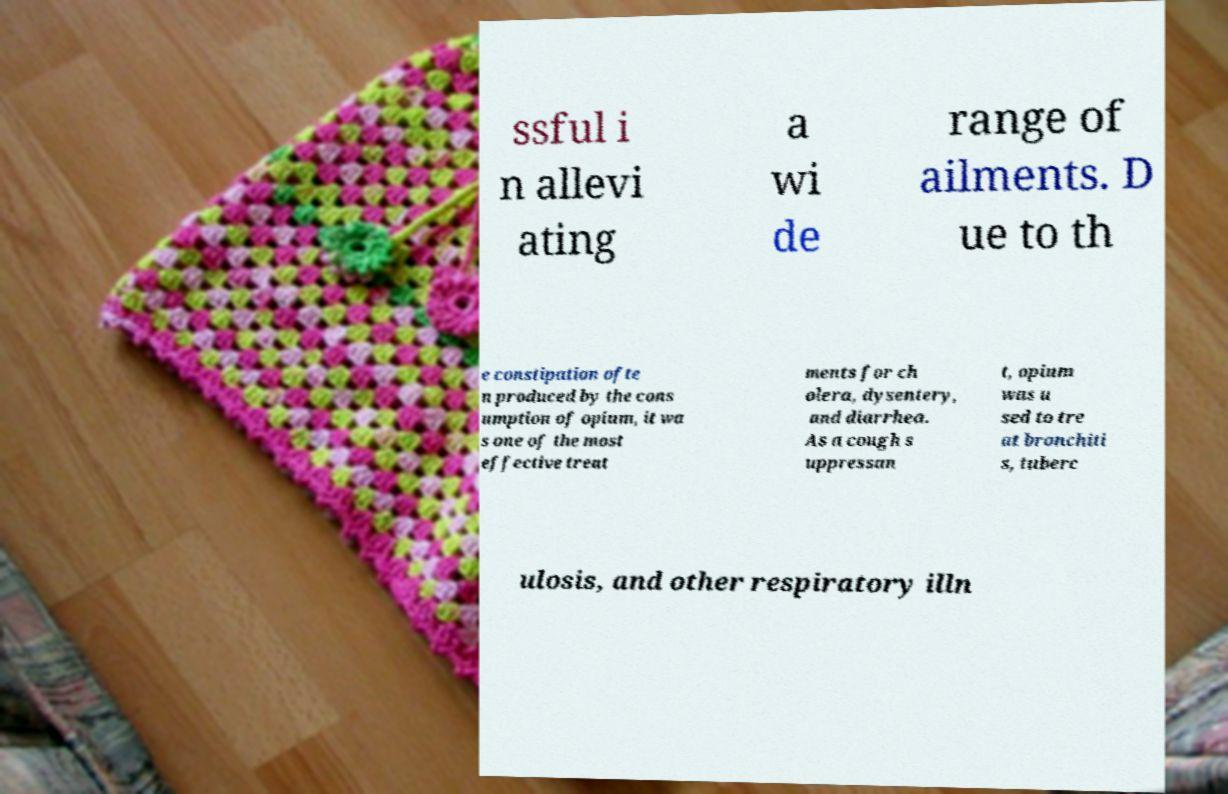Please identify and transcribe the text found in this image. ssful i n allevi ating a wi de range of ailments. D ue to th e constipation ofte n produced by the cons umption of opium, it wa s one of the most effective treat ments for ch olera, dysentery, and diarrhea. As a cough s uppressan t, opium was u sed to tre at bronchiti s, tuberc ulosis, and other respiratory illn 